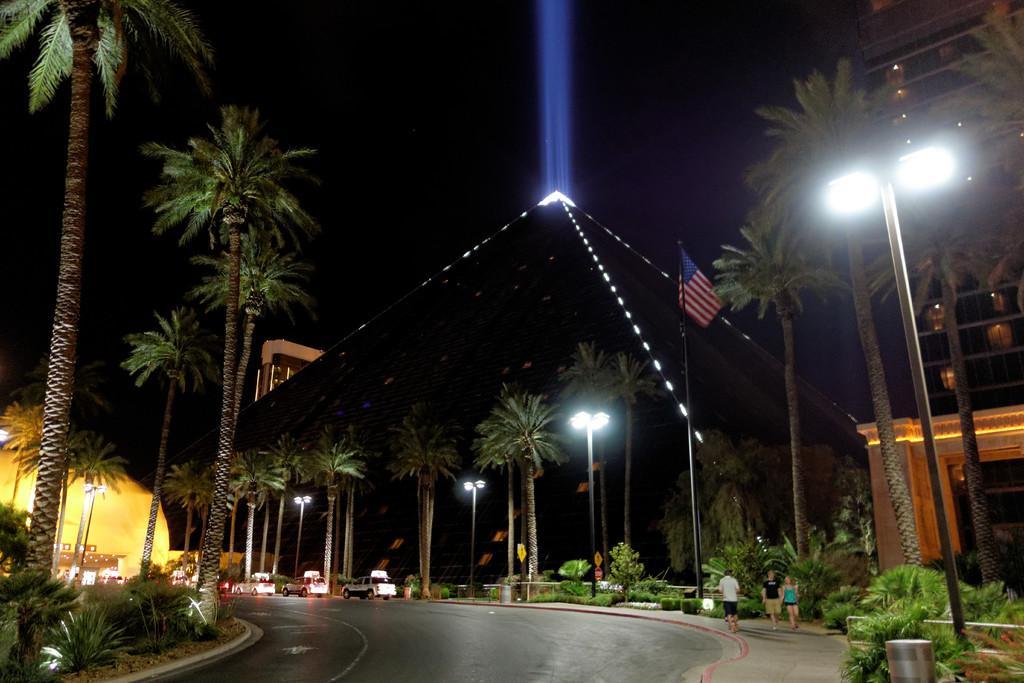Can you describe this image briefly? In this picture we can see plants, trees, poles, lights and a flag, there is a building on the right side, we can see some vehicles on the road, on the right side there are three persons walking, we can see a dark background. 